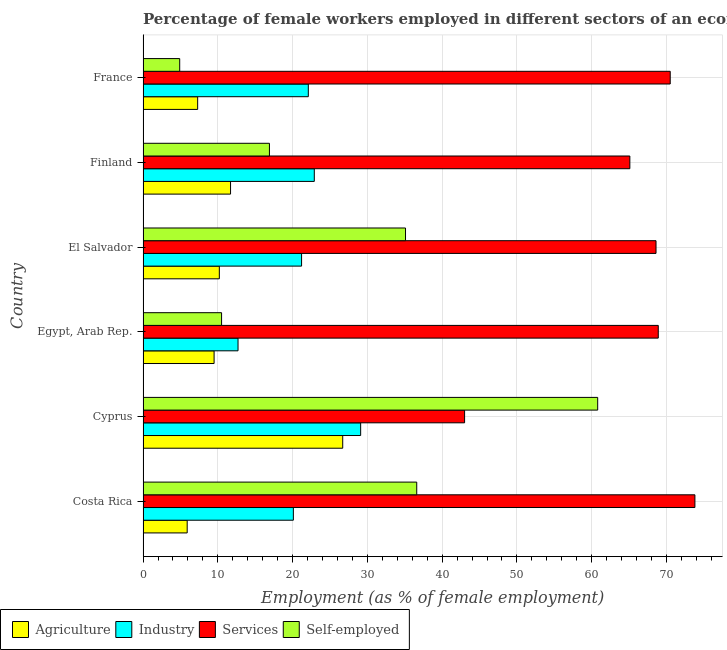What is the label of the 4th group of bars from the top?
Ensure brevity in your answer.  Egypt, Arab Rep. What is the percentage of female workers in industry in Egypt, Arab Rep.?
Your answer should be very brief. 12.7. Across all countries, what is the maximum percentage of female workers in agriculture?
Provide a short and direct response. 26.7. Across all countries, what is the minimum percentage of self employed female workers?
Your answer should be compact. 4.9. In which country was the percentage of female workers in industry maximum?
Make the answer very short. Cyprus. In which country was the percentage of female workers in industry minimum?
Provide a short and direct response. Egypt, Arab Rep. What is the total percentage of female workers in industry in the graph?
Provide a succinct answer. 128.1. What is the difference between the percentage of self employed female workers in Costa Rica and that in France?
Make the answer very short. 31.7. What is the difference between the percentage of female workers in agriculture in Costa Rica and the percentage of female workers in services in Cyprus?
Your answer should be compact. -37.1. What is the average percentage of female workers in agriculture per country?
Ensure brevity in your answer.  11.88. In how many countries, is the percentage of female workers in agriculture greater than 68 %?
Offer a terse response. 0. What is the ratio of the percentage of female workers in services in Costa Rica to that in Egypt, Arab Rep.?
Keep it short and to the point. 1.07. Is the percentage of female workers in agriculture in El Salvador less than that in France?
Offer a terse response. No. Is the difference between the percentage of female workers in services in Finland and France greater than the difference between the percentage of female workers in agriculture in Finland and France?
Offer a very short reply. No. What is the difference between the highest and the second highest percentage of female workers in agriculture?
Provide a succinct answer. 15. What is the difference between the highest and the lowest percentage of female workers in agriculture?
Offer a very short reply. 20.8. Is the sum of the percentage of female workers in services in Costa Rica and Egypt, Arab Rep. greater than the maximum percentage of self employed female workers across all countries?
Offer a terse response. Yes. What does the 2nd bar from the top in Cyprus represents?
Ensure brevity in your answer.  Services. What does the 3rd bar from the bottom in Egypt, Arab Rep. represents?
Your answer should be compact. Services. Is it the case that in every country, the sum of the percentage of female workers in agriculture and percentage of female workers in industry is greater than the percentage of female workers in services?
Offer a terse response. No. How many bars are there?
Keep it short and to the point. 24. How many countries are there in the graph?
Ensure brevity in your answer.  6. What is the difference between two consecutive major ticks on the X-axis?
Make the answer very short. 10. Does the graph contain any zero values?
Provide a short and direct response. No. Where does the legend appear in the graph?
Ensure brevity in your answer.  Bottom left. How are the legend labels stacked?
Ensure brevity in your answer.  Horizontal. What is the title of the graph?
Your answer should be very brief. Percentage of female workers employed in different sectors of an economy in 1980. Does "Overall level" appear as one of the legend labels in the graph?
Your answer should be compact. No. What is the label or title of the X-axis?
Offer a terse response. Employment (as % of female employment). What is the label or title of the Y-axis?
Your response must be concise. Country. What is the Employment (as % of female employment) in Agriculture in Costa Rica?
Offer a very short reply. 5.9. What is the Employment (as % of female employment) in Industry in Costa Rica?
Your response must be concise. 20.1. What is the Employment (as % of female employment) of Services in Costa Rica?
Your answer should be very brief. 73.8. What is the Employment (as % of female employment) of Self-employed in Costa Rica?
Provide a succinct answer. 36.6. What is the Employment (as % of female employment) in Agriculture in Cyprus?
Your response must be concise. 26.7. What is the Employment (as % of female employment) in Industry in Cyprus?
Offer a terse response. 29.1. What is the Employment (as % of female employment) in Self-employed in Cyprus?
Your response must be concise. 60.8. What is the Employment (as % of female employment) in Industry in Egypt, Arab Rep.?
Your answer should be very brief. 12.7. What is the Employment (as % of female employment) in Services in Egypt, Arab Rep.?
Your answer should be compact. 68.9. What is the Employment (as % of female employment) of Self-employed in Egypt, Arab Rep.?
Your response must be concise. 10.5. What is the Employment (as % of female employment) in Agriculture in El Salvador?
Offer a very short reply. 10.2. What is the Employment (as % of female employment) of Industry in El Salvador?
Give a very brief answer. 21.2. What is the Employment (as % of female employment) in Services in El Salvador?
Your answer should be compact. 68.6. What is the Employment (as % of female employment) of Self-employed in El Salvador?
Provide a succinct answer. 35.1. What is the Employment (as % of female employment) in Agriculture in Finland?
Offer a very short reply. 11.7. What is the Employment (as % of female employment) in Industry in Finland?
Make the answer very short. 22.9. What is the Employment (as % of female employment) in Services in Finland?
Offer a very short reply. 65.1. What is the Employment (as % of female employment) of Self-employed in Finland?
Provide a succinct answer. 16.9. What is the Employment (as % of female employment) of Agriculture in France?
Provide a succinct answer. 7.3. What is the Employment (as % of female employment) of Industry in France?
Offer a terse response. 22.1. What is the Employment (as % of female employment) in Services in France?
Give a very brief answer. 70.5. What is the Employment (as % of female employment) in Self-employed in France?
Provide a short and direct response. 4.9. Across all countries, what is the maximum Employment (as % of female employment) of Agriculture?
Offer a terse response. 26.7. Across all countries, what is the maximum Employment (as % of female employment) of Industry?
Make the answer very short. 29.1. Across all countries, what is the maximum Employment (as % of female employment) of Services?
Your answer should be compact. 73.8. Across all countries, what is the maximum Employment (as % of female employment) of Self-employed?
Your response must be concise. 60.8. Across all countries, what is the minimum Employment (as % of female employment) in Agriculture?
Offer a terse response. 5.9. Across all countries, what is the minimum Employment (as % of female employment) in Industry?
Make the answer very short. 12.7. Across all countries, what is the minimum Employment (as % of female employment) in Self-employed?
Keep it short and to the point. 4.9. What is the total Employment (as % of female employment) of Agriculture in the graph?
Provide a succinct answer. 71.3. What is the total Employment (as % of female employment) in Industry in the graph?
Offer a terse response. 128.1. What is the total Employment (as % of female employment) of Services in the graph?
Your answer should be very brief. 389.9. What is the total Employment (as % of female employment) in Self-employed in the graph?
Your answer should be compact. 164.8. What is the difference between the Employment (as % of female employment) in Agriculture in Costa Rica and that in Cyprus?
Your answer should be compact. -20.8. What is the difference between the Employment (as % of female employment) of Industry in Costa Rica and that in Cyprus?
Provide a succinct answer. -9. What is the difference between the Employment (as % of female employment) of Services in Costa Rica and that in Cyprus?
Keep it short and to the point. 30.8. What is the difference between the Employment (as % of female employment) of Self-employed in Costa Rica and that in Cyprus?
Offer a terse response. -24.2. What is the difference between the Employment (as % of female employment) of Self-employed in Costa Rica and that in Egypt, Arab Rep.?
Offer a very short reply. 26.1. What is the difference between the Employment (as % of female employment) of Agriculture in Costa Rica and that in El Salvador?
Offer a terse response. -4.3. What is the difference between the Employment (as % of female employment) of Industry in Costa Rica and that in El Salvador?
Offer a terse response. -1.1. What is the difference between the Employment (as % of female employment) of Services in Costa Rica and that in El Salvador?
Provide a succinct answer. 5.2. What is the difference between the Employment (as % of female employment) in Self-employed in Costa Rica and that in El Salvador?
Offer a very short reply. 1.5. What is the difference between the Employment (as % of female employment) of Industry in Costa Rica and that in Finland?
Your response must be concise. -2.8. What is the difference between the Employment (as % of female employment) in Self-employed in Costa Rica and that in Finland?
Provide a succinct answer. 19.7. What is the difference between the Employment (as % of female employment) of Industry in Costa Rica and that in France?
Keep it short and to the point. -2. What is the difference between the Employment (as % of female employment) in Self-employed in Costa Rica and that in France?
Offer a terse response. 31.7. What is the difference between the Employment (as % of female employment) in Industry in Cyprus and that in Egypt, Arab Rep.?
Offer a terse response. 16.4. What is the difference between the Employment (as % of female employment) of Services in Cyprus and that in Egypt, Arab Rep.?
Ensure brevity in your answer.  -25.9. What is the difference between the Employment (as % of female employment) in Self-employed in Cyprus and that in Egypt, Arab Rep.?
Offer a terse response. 50.3. What is the difference between the Employment (as % of female employment) of Industry in Cyprus and that in El Salvador?
Ensure brevity in your answer.  7.9. What is the difference between the Employment (as % of female employment) in Services in Cyprus and that in El Salvador?
Provide a succinct answer. -25.6. What is the difference between the Employment (as % of female employment) in Self-employed in Cyprus and that in El Salvador?
Your answer should be very brief. 25.7. What is the difference between the Employment (as % of female employment) of Agriculture in Cyprus and that in Finland?
Make the answer very short. 15. What is the difference between the Employment (as % of female employment) of Industry in Cyprus and that in Finland?
Keep it short and to the point. 6.2. What is the difference between the Employment (as % of female employment) in Services in Cyprus and that in Finland?
Your answer should be compact. -22.1. What is the difference between the Employment (as % of female employment) of Self-employed in Cyprus and that in Finland?
Your answer should be very brief. 43.9. What is the difference between the Employment (as % of female employment) of Services in Cyprus and that in France?
Make the answer very short. -27.5. What is the difference between the Employment (as % of female employment) of Self-employed in Cyprus and that in France?
Provide a short and direct response. 55.9. What is the difference between the Employment (as % of female employment) in Self-employed in Egypt, Arab Rep. and that in El Salvador?
Offer a terse response. -24.6. What is the difference between the Employment (as % of female employment) of Industry in Egypt, Arab Rep. and that in Finland?
Your answer should be very brief. -10.2. What is the difference between the Employment (as % of female employment) of Industry in Egypt, Arab Rep. and that in France?
Offer a terse response. -9.4. What is the difference between the Employment (as % of female employment) in Services in Egypt, Arab Rep. and that in France?
Ensure brevity in your answer.  -1.6. What is the difference between the Employment (as % of female employment) of Self-employed in Egypt, Arab Rep. and that in France?
Provide a succinct answer. 5.6. What is the difference between the Employment (as % of female employment) in Agriculture in El Salvador and that in Finland?
Offer a terse response. -1.5. What is the difference between the Employment (as % of female employment) of Industry in El Salvador and that in Finland?
Your answer should be very brief. -1.7. What is the difference between the Employment (as % of female employment) in Services in El Salvador and that in Finland?
Your answer should be compact. 3.5. What is the difference between the Employment (as % of female employment) of Self-employed in El Salvador and that in Finland?
Ensure brevity in your answer.  18.2. What is the difference between the Employment (as % of female employment) of Industry in El Salvador and that in France?
Offer a terse response. -0.9. What is the difference between the Employment (as % of female employment) of Self-employed in El Salvador and that in France?
Give a very brief answer. 30.2. What is the difference between the Employment (as % of female employment) of Agriculture in Finland and that in France?
Ensure brevity in your answer.  4.4. What is the difference between the Employment (as % of female employment) in Self-employed in Finland and that in France?
Your answer should be very brief. 12. What is the difference between the Employment (as % of female employment) in Agriculture in Costa Rica and the Employment (as % of female employment) in Industry in Cyprus?
Ensure brevity in your answer.  -23.2. What is the difference between the Employment (as % of female employment) of Agriculture in Costa Rica and the Employment (as % of female employment) of Services in Cyprus?
Provide a short and direct response. -37.1. What is the difference between the Employment (as % of female employment) of Agriculture in Costa Rica and the Employment (as % of female employment) of Self-employed in Cyprus?
Your answer should be compact. -54.9. What is the difference between the Employment (as % of female employment) in Industry in Costa Rica and the Employment (as % of female employment) in Services in Cyprus?
Your answer should be compact. -22.9. What is the difference between the Employment (as % of female employment) in Industry in Costa Rica and the Employment (as % of female employment) in Self-employed in Cyprus?
Your response must be concise. -40.7. What is the difference between the Employment (as % of female employment) in Agriculture in Costa Rica and the Employment (as % of female employment) in Industry in Egypt, Arab Rep.?
Ensure brevity in your answer.  -6.8. What is the difference between the Employment (as % of female employment) in Agriculture in Costa Rica and the Employment (as % of female employment) in Services in Egypt, Arab Rep.?
Make the answer very short. -63. What is the difference between the Employment (as % of female employment) of Agriculture in Costa Rica and the Employment (as % of female employment) of Self-employed in Egypt, Arab Rep.?
Offer a very short reply. -4.6. What is the difference between the Employment (as % of female employment) in Industry in Costa Rica and the Employment (as % of female employment) in Services in Egypt, Arab Rep.?
Provide a succinct answer. -48.8. What is the difference between the Employment (as % of female employment) of Industry in Costa Rica and the Employment (as % of female employment) of Self-employed in Egypt, Arab Rep.?
Give a very brief answer. 9.6. What is the difference between the Employment (as % of female employment) in Services in Costa Rica and the Employment (as % of female employment) in Self-employed in Egypt, Arab Rep.?
Provide a short and direct response. 63.3. What is the difference between the Employment (as % of female employment) of Agriculture in Costa Rica and the Employment (as % of female employment) of Industry in El Salvador?
Keep it short and to the point. -15.3. What is the difference between the Employment (as % of female employment) in Agriculture in Costa Rica and the Employment (as % of female employment) in Services in El Salvador?
Provide a short and direct response. -62.7. What is the difference between the Employment (as % of female employment) of Agriculture in Costa Rica and the Employment (as % of female employment) of Self-employed in El Salvador?
Provide a succinct answer. -29.2. What is the difference between the Employment (as % of female employment) in Industry in Costa Rica and the Employment (as % of female employment) in Services in El Salvador?
Offer a terse response. -48.5. What is the difference between the Employment (as % of female employment) of Industry in Costa Rica and the Employment (as % of female employment) of Self-employed in El Salvador?
Your response must be concise. -15. What is the difference between the Employment (as % of female employment) of Services in Costa Rica and the Employment (as % of female employment) of Self-employed in El Salvador?
Give a very brief answer. 38.7. What is the difference between the Employment (as % of female employment) in Agriculture in Costa Rica and the Employment (as % of female employment) in Services in Finland?
Offer a very short reply. -59.2. What is the difference between the Employment (as % of female employment) in Agriculture in Costa Rica and the Employment (as % of female employment) in Self-employed in Finland?
Provide a succinct answer. -11. What is the difference between the Employment (as % of female employment) in Industry in Costa Rica and the Employment (as % of female employment) in Services in Finland?
Your answer should be very brief. -45. What is the difference between the Employment (as % of female employment) of Services in Costa Rica and the Employment (as % of female employment) of Self-employed in Finland?
Offer a terse response. 56.9. What is the difference between the Employment (as % of female employment) of Agriculture in Costa Rica and the Employment (as % of female employment) of Industry in France?
Offer a very short reply. -16.2. What is the difference between the Employment (as % of female employment) of Agriculture in Costa Rica and the Employment (as % of female employment) of Services in France?
Keep it short and to the point. -64.6. What is the difference between the Employment (as % of female employment) in Agriculture in Costa Rica and the Employment (as % of female employment) in Self-employed in France?
Give a very brief answer. 1. What is the difference between the Employment (as % of female employment) of Industry in Costa Rica and the Employment (as % of female employment) of Services in France?
Keep it short and to the point. -50.4. What is the difference between the Employment (as % of female employment) of Industry in Costa Rica and the Employment (as % of female employment) of Self-employed in France?
Offer a very short reply. 15.2. What is the difference between the Employment (as % of female employment) of Services in Costa Rica and the Employment (as % of female employment) of Self-employed in France?
Provide a short and direct response. 68.9. What is the difference between the Employment (as % of female employment) of Agriculture in Cyprus and the Employment (as % of female employment) of Services in Egypt, Arab Rep.?
Your answer should be compact. -42.2. What is the difference between the Employment (as % of female employment) of Agriculture in Cyprus and the Employment (as % of female employment) of Self-employed in Egypt, Arab Rep.?
Provide a short and direct response. 16.2. What is the difference between the Employment (as % of female employment) of Industry in Cyprus and the Employment (as % of female employment) of Services in Egypt, Arab Rep.?
Give a very brief answer. -39.8. What is the difference between the Employment (as % of female employment) in Industry in Cyprus and the Employment (as % of female employment) in Self-employed in Egypt, Arab Rep.?
Offer a very short reply. 18.6. What is the difference between the Employment (as % of female employment) in Services in Cyprus and the Employment (as % of female employment) in Self-employed in Egypt, Arab Rep.?
Ensure brevity in your answer.  32.5. What is the difference between the Employment (as % of female employment) in Agriculture in Cyprus and the Employment (as % of female employment) in Industry in El Salvador?
Ensure brevity in your answer.  5.5. What is the difference between the Employment (as % of female employment) in Agriculture in Cyprus and the Employment (as % of female employment) in Services in El Salvador?
Your response must be concise. -41.9. What is the difference between the Employment (as % of female employment) in Industry in Cyprus and the Employment (as % of female employment) in Services in El Salvador?
Offer a very short reply. -39.5. What is the difference between the Employment (as % of female employment) in Industry in Cyprus and the Employment (as % of female employment) in Self-employed in El Salvador?
Your response must be concise. -6. What is the difference between the Employment (as % of female employment) in Services in Cyprus and the Employment (as % of female employment) in Self-employed in El Salvador?
Keep it short and to the point. 7.9. What is the difference between the Employment (as % of female employment) of Agriculture in Cyprus and the Employment (as % of female employment) of Industry in Finland?
Provide a succinct answer. 3.8. What is the difference between the Employment (as % of female employment) of Agriculture in Cyprus and the Employment (as % of female employment) of Services in Finland?
Give a very brief answer. -38.4. What is the difference between the Employment (as % of female employment) in Agriculture in Cyprus and the Employment (as % of female employment) in Self-employed in Finland?
Your answer should be very brief. 9.8. What is the difference between the Employment (as % of female employment) in Industry in Cyprus and the Employment (as % of female employment) in Services in Finland?
Offer a terse response. -36. What is the difference between the Employment (as % of female employment) of Industry in Cyprus and the Employment (as % of female employment) of Self-employed in Finland?
Provide a succinct answer. 12.2. What is the difference between the Employment (as % of female employment) of Services in Cyprus and the Employment (as % of female employment) of Self-employed in Finland?
Offer a terse response. 26.1. What is the difference between the Employment (as % of female employment) in Agriculture in Cyprus and the Employment (as % of female employment) in Industry in France?
Offer a terse response. 4.6. What is the difference between the Employment (as % of female employment) of Agriculture in Cyprus and the Employment (as % of female employment) of Services in France?
Keep it short and to the point. -43.8. What is the difference between the Employment (as % of female employment) in Agriculture in Cyprus and the Employment (as % of female employment) in Self-employed in France?
Ensure brevity in your answer.  21.8. What is the difference between the Employment (as % of female employment) of Industry in Cyprus and the Employment (as % of female employment) of Services in France?
Ensure brevity in your answer.  -41.4. What is the difference between the Employment (as % of female employment) of Industry in Cyprus and the Employment (as % of female employment) of Self-employed in France?
Your answer should be compact. 24.2. What is the difference between the Employment (as % of female employment) in Services in Cyprus and the Employment (as % of female employment) in Self-employed in France?
Provide a short and direct response. 38.1. What is the difference between the Employment (as % of female employment) of Agriculture in Egypt, Arab Rep. and the Employment (as % of female employment) of Services in El Salvador?
Ensure brevity in your answer.  -59.1. What is the difference between the Employment (as % of female employment) in Agriculture in Egypt, Arab Rep. and the Employment (as % of female employment) in Self-employed in El Salvador?
Offer a terse response. -25.6. What is the difference between the Employment (as % of female employment) in Industry in Egypt, Arab Rep. and the Employment (as % of female employment) in Services in El Salvador?
Make the answer very short. -55.9. What is the difference between the Employment (as % of female employment) of Industry in Egypt, Arab Rep. and the Employment (as % of female employment) of Self-employed in El Salvador?
Provide a succinct answer. -22.4. What is the difference between the Employment (as % of female employment) in Services in Egypt, Arab Rep. and the Employment (as % of female employment) in Self-employed in El Salvador?
Make the answer very short. 33.8. What is the difference between the Employment (as % of female employment) in Agriculture in Egypt, Arab Rep. and the Employment (as % of female employment) in Services in Finland?
Offer a very short reply. -55.6. What is the difference between the Employment (as % of female employment) in Agriculture in Egypt, Arab Rep. and the Employment (as % of female employment) in Self-employed in Finland?
Make the answer very short. -7.4. What is the difference between the Employment (as % of female employment) in Industry in Egypt, Arab Rep. and the Employment (as % of female employment) in Services in Finland?
Make the answer very short. -52.4. What is the difference between the Employment (as % of female employment) of Industry in Egypt, Arab Rep. and the Employment (as % of female employment) of Self-employed in Finland?
Offer a terse response. -4.2. What is the difference between the Employment (as % of female employment) of Services in Egypt, Arab Rep. and the Employment (as % of female employment) of Self-employed in Finland?
Your answer should be very brief. 52. What is the difference between the Employment (as % of female employment) of Agriculture in Egypt, Arab Rep. and the Employment (as % of female employment) of Services in France?
Your answer should be compact. -61. What is the difference between the Employment (as % of female employment) in Industry in Egypt, Arab Rep. and the Employment (as % of female employment) in Services in France?
Provide a short and direct response. -57.8. What is the difference between the Employment (as % of female employment) in Agriculture in El Salvador and the Employment (as % of female employment) in Industry in Finland?
Provide a succinct answer. -12.7. What is the difference between the Employment (as % of female employment) in Agriculture in El Salvador and the Employment (as % of female employment) in Services in Finland?
Offer a very short reply. -54.9. What is the difference between the Employment (as % of female employment) in Agriculture in El Salvador and the Employment (as % of female employment) in Self-employed in Finland?
Keep it short and to the point. -6.7. What is the difference between the Employment (as % of female employment) of Industry in El Salvador and the Employment (as % of female employment) of Services in Finland?
Make the answer very short. -43.9. What is the difference between the Employment (as % of female employment) of Industry in El Salvador and the Employment (as % of female employment) of Self-employed in Finland?
Provide a short and direct response. 4.3. What is the difference between the Employment (as % of female employment) of Services in El Salvador and the Employment (as % of female employment) of Self-employed in Finland?
Offer a very short reply. 51.7. What is the difference between the Employment (as % of female employment) in Agriculture in El Salvador and the Employment (as % of female employment) in Industry in France?
Your response must be concise. -11.9. What is the difference between the Employment (as % of female employment) of Agriculture in El Salvador and the Employment (as % of female employment) of Services in France?
Provide a succinct answer. -60.3. What is the difference between the Employment (as % of female employment) of Industry in El Salvador and the Employment (as % of female employment) of Services in France?
Offer a terse response. -49.3. What is the difference between the Employment (as % of female employment) of Industry in El Salvador and the Employment (as % of female employment) of Self-employed in France?
Offer a very short reply. 16.3. What is the difference between the Employment (as % of female employment) of Services in El Salvador and the Employment (as % of female employment) of Self-employed in France?
Make the answer very short. 63.7. What is the difference between the Employment (as % of female employment) of Agriculture in Finland and the Employment (as % of female employment) of Services in France?
Offer a terse response. -58.8. What is the difference between the Employment (as % of female employment) in Agriculture in Finland and the Employment (as % of female employment) in Self-employed in France?
Provide a short and direct response. 6.8. What is the difference between the Employment (as % of female employment) of Industry in Finland and the Employment (as % of female employment) of Services in France?
Provide a succinct answer. -47.6. What is the difference between the Employment (as % of female employment) of Industry in Finland and the Employment (as % of female employment) of Self-employed in France?
Give a very brief answer. 18. What is the difference between the Employment (as % of female employment) of Services in Finland and the Employment (as % of female employment) of Self-employed in France?
Your answer should be compact. 60.2. What is the average Employment (as % of female employment) of Agriculture per country?
Provide a succinct answer. 11.88. What is the average Employment (as % of female employment) of Industry per country?
Offer a terse response. 21.35. What is the average Employment (as % of female employment) of Services per country?
Make the answer very short. 64.98. What is the average Employment (as % of female employment) of Self-employed per country?
Keep it short and to the point. 27.47. What is the difference between the Employment (as % of female employment) of Agriculture and Employment (as % of female employment) of Industry in Costa Rica?
Provide a succinct answer. -14.2. What is the difference between the Employment (as % of female employment) of Agriculture and Employment (as % of female employment) of Services in Costa Rica?
Your answer should be compact. -67.9. What is the difference between the Employment (as % of female employment) of Agriculture and Employment (as % of female employment) of Self-employed in Costa Rica?
Your answer should be compact. -30.7. What is the difference between the Employment (as % of female employment) in Industry and Employment (as % of female employment) in Services in Costa Rica?
Make the answer very short. -53.7. What is the difference between the Employment (as % of female employment) of Industry and Employment (as % of female employment) of Self-employed in Costa Rica?
Ensure brevity in your answer.  -16.5. What is the difference between the Employment (as % of female employment) of Services and Employment (as % of female employment) of Self-employed in Costa Rica?
Provide a short and direct response. 37.2. What is the difference between the Employment (as % of female employment) in Agriculture and Employment (as % of female employment) in Industry in Cyprus?
Provide a succinct answer. -2.4. What is the difference between the Employment (as % of female employment) in Agriculture and Employment (as % of female employment) in Services in Cyprus?
Keep it short and to the point. -16.3. What is the difference between the Employment (as % of female employment) of Agriculture and Employment (as % of female employment) of Self-employed in Cyprus?
Offer a very short reply. -34.1. What is the difference between the Employment (as % of female employment) in Industry and Employment (as % of female employment) in Services in Cyprus?
Keep it short and to the point. -13.9. What is the difference between the Employment (as % of female employment) in Industry and Employment (as % of female employment) in Self-employed in Cyprus?
Provide a succinct answer. -31.7. What is the difference between the Employment (as % of female employment) in Services and Employment (as % of female employment) in Self-employed in Cyprus?
Offer a terse response. -17.8. What is the difference between the Employment (as % of female employment) in Agriculture and Employment (as % of female employment) in Services in Egypt, Arab Rep.?
Give a very brief answer. -59.4. What is the difference between the Employment (as % of female employment) of Agriculture and Employment (as % of female employment) of Self-employed in Egypt, Arab Rep.?
Offer a terse response. -1. What is the difference between the Employment (as % of female employment) in Industry and Employment (as % of female employment) in Services in Egypt, Arab Rep.?
Your answer should be compact. -56.2. What is the difference between the Employment (as % of female employment) in Industry and Employment (as % of female employment) in Self-employed in Egypt, Arab Rep.?
Offer a very short reply. 2.2. What is the difference between the Employment (as % of female employment) of Services and Employment (as % of female employment) of Self-employed in Egypt, Arab Rep.?
Provide a short and direct response. 58.4. What is the difference between the Employment (as % of female employment) in Agriculture and Employment (as % of female employment) in Services in El Salvador?
Your answer should be compact. -58.4. What is the difference between the Employment (as % of female employment) of Agriculture and Employment (as % of female employment) of Self-employed in El Salvador?
Ensure brevity in your answer.  -24.9. What is the difference between the Employment (as % of female employment) in Industry and Employment (as % of female employment) in Services in El Salvador?
Your response must be concise. -47.4. What is the difference between the Employment (as % of female employment) of Industry and Employment (as % of female employment) of Self-employed in El Salvador?
Keep it short and to the point. -13.9. What is the difference between the Employment (as % of female employment) in Services and Employment (as % of female employment) in Self-employed in El Salvador?
Ensure brevity in your answer.  33.5. What is the difference between the Employment (as % of female employment) of Agriculture and Employment (as % of female employment) of Services in Finland?
Your answer should be very brief. -53.4. What is the difference between the Employment (as % of female employment) in Agriculture and Employment (as % of female employment) in Self-employed in Finland?
Offer a very short reply. -5.2. What is the difference between the Employment (as % of female employment) of Industry and Employment (as % of female employment) of Services in Finland?
Your answer should be compact. -42.2. What is the difference between the Employment (as % of female employment) of Industry and Employment (as % of female employment) of Self-employed in Finland?
Provide a short and direct response. 6. What is the difference between the Employment (as % of female employment) of Services and Employment (as % of female employment) of Self-employed in Finland?
Provide a succinct answer. 48.2. What is the difference between the Employment (as % of female employment) in Agriculture and Employment (as % of female employment) in Industry in France?
Offer a very short reply. -14.8. What is the difference between the Employment (as % of female employment) in Agriculture and Employment (as % of female employment) in Services in France?
Offer a terse response. -63.2. What is the difference between the Employment (as % of female employment) of Agriculture and Employment (as % of female employment) of Self-employed in France?
Ensure brevity in your answer.  2.4. What is the difference between the Employment (as % of female employment) in Industry and Employment (as % of female employment) in Services in France?
Keep it short and to the point. -48.4. What is the difference between the Employment (as % of female employment) of Services and Employment (as % of female employment) of Self-employed in France?
Your answer should be very brief. 65.6. What is the ratio of the Employment (as % of female employment) in Agriculture in Costa Rica to that in Cyprus?
Offer a very short reply. 0.22. What is the ratio of the Employment (as % of female employment) in Industry in Costa Rica to that in Cyprus?
Offer a terse response. 0.69. What is the ratio of the Employment (as % of female employment) of Services in Costa Rica to that in Cyprus?
Offer a terse response. 1.72. What is the ratio of the Employment (as % of female employment) of Self-employed in Costa Rica to that in Cyprus?
Give a very brief answer. 0.6. What is the ratio of the Employment (as % of female employment) of Agriculture in Costa Rica to that in Egypt, Arab Rep.?
Your answer should be very brief. 0.62. What is the ratio of the Employment (as % of female employment) of Industry in Costa Rica to that in Egypt, Arab Rep.?
Your answer should be very brief. 1.58. What is the ratio of the Employment (as % of female employment) of Services in Costa Rica to that in Egypt, Arab Rep.?
Your answer should be very brief. 1.07. What is the ratio of the Employment (as % of female employment) of Self-employed in Costa Rica to that in Egypt, Arab Rep.?
Your response must be concise. 3.49. What is the ratio of the Employment (as % of female employment) in Agriculture in Costa Rica to that in El Salvador?
Offer a terse response. 0.58. What is the ratio of the Employment (as % of female employment) of Industry in Costa Rica to that in El Salvador?
Your answer should be very brief. 0.95. What is the ratio of the Employment (as % of female employment) of Services in Costa Rica to that in El Salvador?
Provide a succinct answer. 1.08. What is the ratio of the Employment (as % of female employment) of Self-employed in Costa Rica to that in El Salvador?
Provide a short and direct response. 1.04. What is the ratio of the Employment (as % of female employment) of Agriculture in Costa Rica to that in Finland?
Offer a very short reply. 0.5. What is the ratio of the Employment (as % of female employment) of Industry in Costa Rica to that in Finland?
Provide a short and direct response. 0.88. What is the ratio of the Employment (as % of female employment) of Services in Costa Rica to that in Finland?
Give a very brief answer. 1.13. What is the ratio of the Employment (as % of female employment) of Self-employed in Costa Rica to that in Finland?
Make the answer very short. 2.17. What is the ratio of the Employment (as % of female employment) of Agriculture in Costa Rica to that in France?
Ensure brevity in your answer.  0.81. What is the ratio of the Employment (as % of female employment) of Industry in Costa Rica to that in France?
Keep it short and to the point. 0.91. What is the ratio of the Employment (as % of female employment) of Services in Costa Rica to that in France?
Ensure brevity in your answer.  1.05. What is the ratio of the Employment (as % of female employment) of Self-employed in Costa Rica to that in France?
Give a very brief answer. 7.47. What is the ratio of the Employment (as % of female employment) of Agriculture in Cyprus to that in Egypt, Arab Rep.?
Give a very brief answer. 2.81. What is the ratio of the Employment (as % of female employment) of Industry in Cyprus to that in Egypt, Arab Rep.?
Your answer should be very brief. 2.29. What is the ratio of the Employment (as % of female employment) in Services in Cyprus to that in Egypt, Arab Rep.?
Provide a short and direct response. 0.62. What is the ratio of the Employment (as % of female employment) of Self-employed in Cyprus to that in Egypt, Arab Rep.?
Make the answer very short. 5.79. What is the ratio of the Employment (as % of female employment) of Agriculture in Cyprus to that in El Salvador?
Give a very brief answer. 2.62. What is the ratio of the Employment (as % of female employment) of Industry in Cyprus to that in El Salvador?
Your response must be concise. 1.37. What is the ratio of the Employment (as % of female employment) of Services in Cyprus to that in El Salvador?
Give a very brief answer. 0.63. What is the ratio of the Employment (as % of female employment) in Self-employed in Cyprus to that in El Salvador?
Offer a terse response. 1.73. What is the ratio of the Employment (as % of female employment) of Agriculture in Cyprus to that in Finland?
Make the answer very short. 2.28. What is the ratio of the Employment (as % of female employment) of Industry in Cyprus to that in Finland?
Your response must be concise. 1.27. What is the ratio of the Employment (as % of female employment) of Services in Cyprus to that in Finland?
Give a very brief answer. 0.66. What is the ratio of the Employment (as % of female employment) of Self-employed in Cyprus to that in Finland?
Provide a short and direct response. 3.6. What is the ratio of the Employment (as % of female employment) of Agriculture in Cyprus to that in France?
Your response must be concise. 3.66. What is the ratio of the Employment (as % of female employment) of Industry in Cyprus to that in France?
Your response must be concise. 1.32. What is the ratio of the Employment (as % of female employment) in Services in Cyprus to that in France?
Offer a terse response. 0.61. What is the ratio of the Employment (as % of female employment) in Self-employed in Cyprus to that in France?
Your answer should be compact. 12.41. What is the ratio of the Employment (as % of female employment) in Agriculture in Egypt, Arab Rep. to that in El Salvador?
Your answer should be compact. 0.93. What is the ratio of the Employment (as % of female employment) of Industry in Egypt, Arab Rep. to that in El Salvador?
Offer a very short reply. 0.6. What is the ratio of the Employment (as % of female employment) of Self-employed in Egypt, Arab Rep. to that in El Salvador?
Offer a terse response. 0.3. What is the ratio of the Employment (as % of female employment) of Agriculture in Egypt, Arab Rep. to that in Finland?
Your answer should be very brief. 0.81. What is the ratio of the Employment (as % of female employment) in Industry in Egypt, Arab Rep. to that in Finland?
Offer a terse response. 0.55. What is the ratio of the Employment (as % of female employment) in Services in Egypt, Arab Rep. to that in Finland?
Ensure brevity in your answer.  1.06. What is the ratio of the Employment (as % of female employment) in Self-employed in Egypt, Arab Rep. to that in Finland?
Your answer should be compact. 0.62. What is the ratio of the Employment (as % of female employment) of Agriculture in Egypt, Arab Rep. to that in France?
Your answer should be compact. 1.3. What is the ratio of the Employment (as % of female employment) in Industry in Egypt, Arab Rep. to that in France?
Your response must be concise. 0.57. What is the ratio of the Employment (as % of female employment) in Services in Egypt, Arab Rep. to that in France?
Offer a very short reply. 0.98. What is the ratio of the Employment (as % of female employment) of Self-employed in Egypt, Arab Rep. to that in France?
Keep it short and to the point. 2.14. What is the ratio of the Employment (as % of female employment) of Agriculture in El Salvador to that in Finland?
Offer a very short reply. 0.87. What is the ratio of the Employment (as % of female employment) in Industry in El Salvador to that in Finland?
Give a very brief answer. 0.93. What is the ratio of the Employment (as % of female employment) of Services in El Salvador to that in Finland?
Provide a succinct answer. 1.05. What is the ratio of the Employment (as % of female employment) in Self-employed in El Salvador to that in Finland?
Offer a terse response. 2.08. What is the ratio of the Employment (as % of female employment) in Agriculture in El Salvador to that in France?
Offer a terse response. 1.4. What is the ratio of the Employment (as % of female employment) in Industry in El Salvador to that in France?
Your answer should be very brief. 0.96. What is the ratio of the Employment (as % of female employment) in Self-employed in El Salvador to that in France?
Give a very brief answer. 7.16. What is the ratio of the Employment (as % of female employment) in Agriculture in Finland to that in France?
Make the answer very short. 1.6. What is the ratio of the Employment (as % of female employment) of Industry in Finland to that in France?
Ensure brevity in your answer.  1.04. What is the ratio of the Employment (as % of female employment) of Services in Finland to that in France?
Make the answer very short. 0.92. What is the ratio of the Employment (as % of female employment) of Self-employed in Finland to that in France?
Provide a succinct answer. 3.45. What is the difference between the highest and the second highest Employment (as % of female employment) of Industry?
Your answer should be very brief. 6.2. What is the difference between the highest and the second highest Employment (as % of female employment) of Services?
Your answer should be compact. 3.3. What is the difference between the highest and the second highest Employment (as % of female employment) of Self-employed?
Your answer should be compact. 24.2. What is the difference between the highest and the lowest Employment (as % of female employment) of Agriculture?
Provide a short and direct response. 20.8. What is the difference between the highest and the lowest Employment (as % of female employment) of Industry?
Make the answer very short. 16.4. What is the difference between the highest and the lowest Employment (as % of female employment) of Services?
Your answer should be very brief. 30.8. What is the difference between the highest and the lowest Employment (as % of female employment) in Self-employed?
Your answer should be very brief. 55.9. 